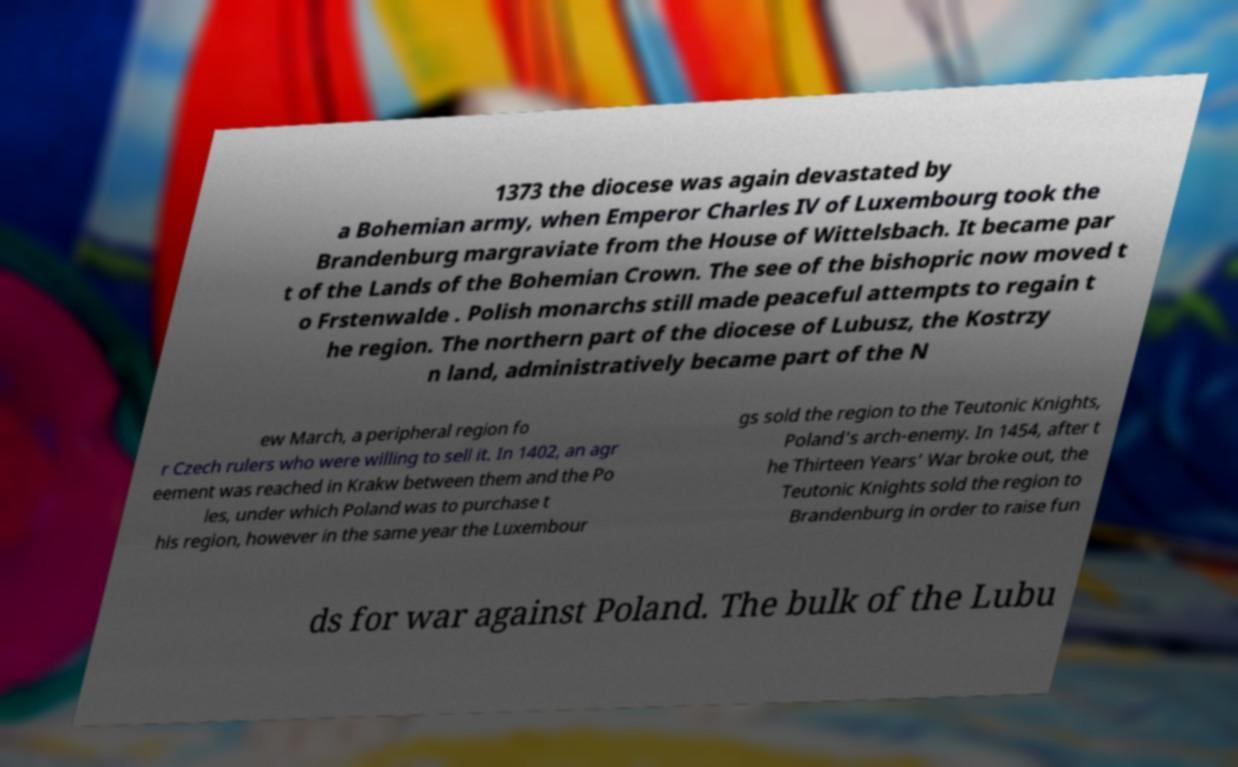What messages or text are displayed in this image? I need them in a readable, typed format. 1373 the diocese was again devastated by a Bohemian army, when Emperor Charles IV of Luxembourg took the Brandenburg margraviate from the House of Wittelsbach. It became par t of the Lands of the Bohemian Crown. The see of the bishopric now moved t o Frstenwalde . Polish monarchs still made peaceful attempts to regain t he region. The northern part of the diocese of Lubusz, the Kostrzy n land, administratively became part of the N ew March, a peripheral region fo r Czech rulers who were willing to sell it. In 1402, an agr eement was reached in Krakw between them and the Po les, under which Poland was to purchase t his region, however in the same year the Luxembour gs sold the region to the Teutonic Knights, Poland's arch-enemy. In 1454, after t he Thirteen Years’ War broke out, the Teutonic Knights sold the region to Brandenburg in order to raise fun ds for war against Poland. The bulk of the Lubu 